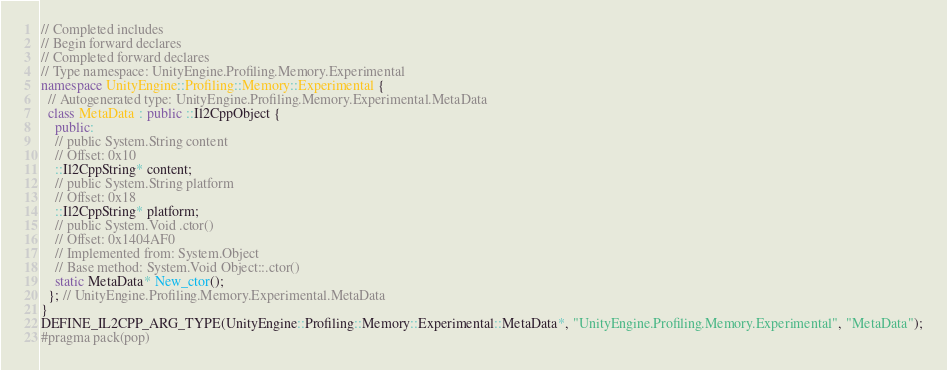<code> <loc_0><loc_0><loc_500><loc_500><_C++_>// Completed includes
// Begin forward declares
// Completed forward declares
// Type namespace: UnityEngine.Profiling.Memory.Experimental
namespace UnityEngine::Profiling::Memory::Experimental {
  // Autogenerated type: UnityEngine.Profiling.Memory.Experimental.MetaData
  class MetaData : public ::Il2CppObject {
    public:
    // public System.String content
    // Offset: 0x10
    ::Il2CppString* content;
    // public System.String platform
    // Offset: 0x18
    ::Il2CppString* platform;
    // public System.Void .ctor()
    // Offset: 0x1404AF0
    // Implemented from: System.Object
    // Base method: System.Void Object::.ctor()
    static MetaData* New_ctor();
  }; // UnityEngine.Profiling.Memory.Experimental.MetaData
}
DEFINE_IL2CPP_ARG_TYPE(UnityEngine::Profiling::Memory::Experimental::MetaData*, "UnityEngine.Profiling.Memory.Experimental", "MetaData");
#pragma pack(pop)
</code> 